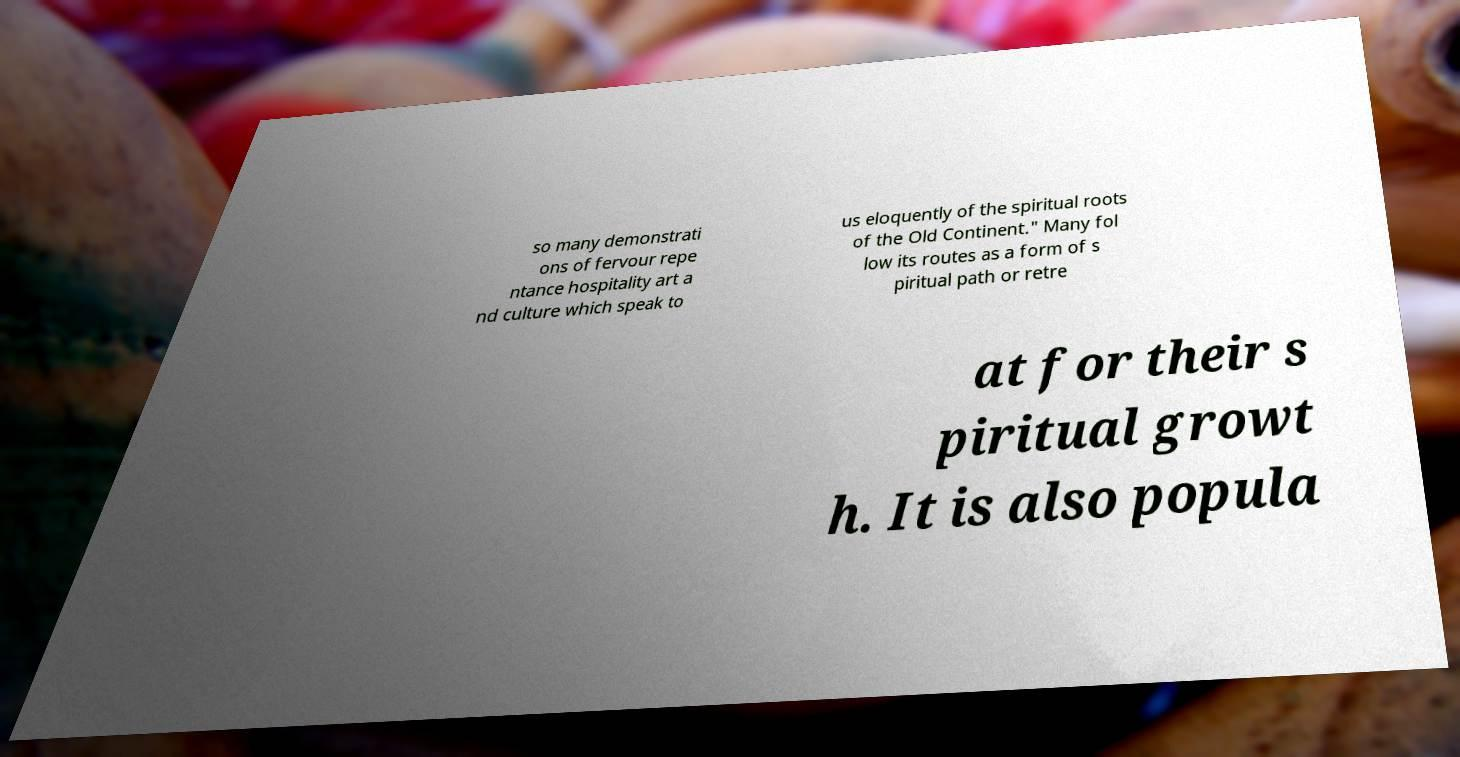What messages or text are displayed in this image? I need them in a readable, typed format. so many demonstrati ons of fervour repe ntance hospitality art a nd culture which speak to us eloquently of the spiritual roots of the Old Continent." Many fol low its routes as a form of s piritual path or retre at for their s piritual growt h. It is also popula 